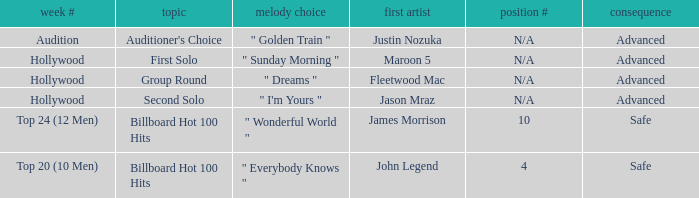What are all of the order # where authentic artist is maroon 5 N/A. 